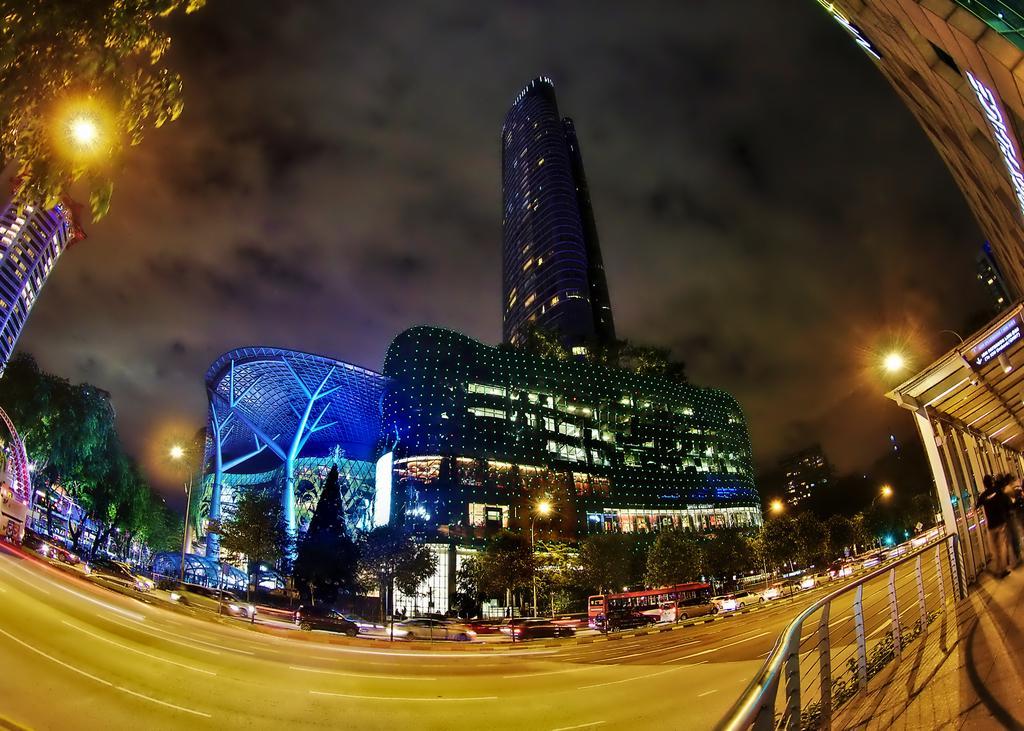How would you summarize this image in a sentence or two? In this image we can see sky with clouds, trees, buildings, motor vehicles on the road, street poles, persons standing on the floor by holding the grills and sheds. 